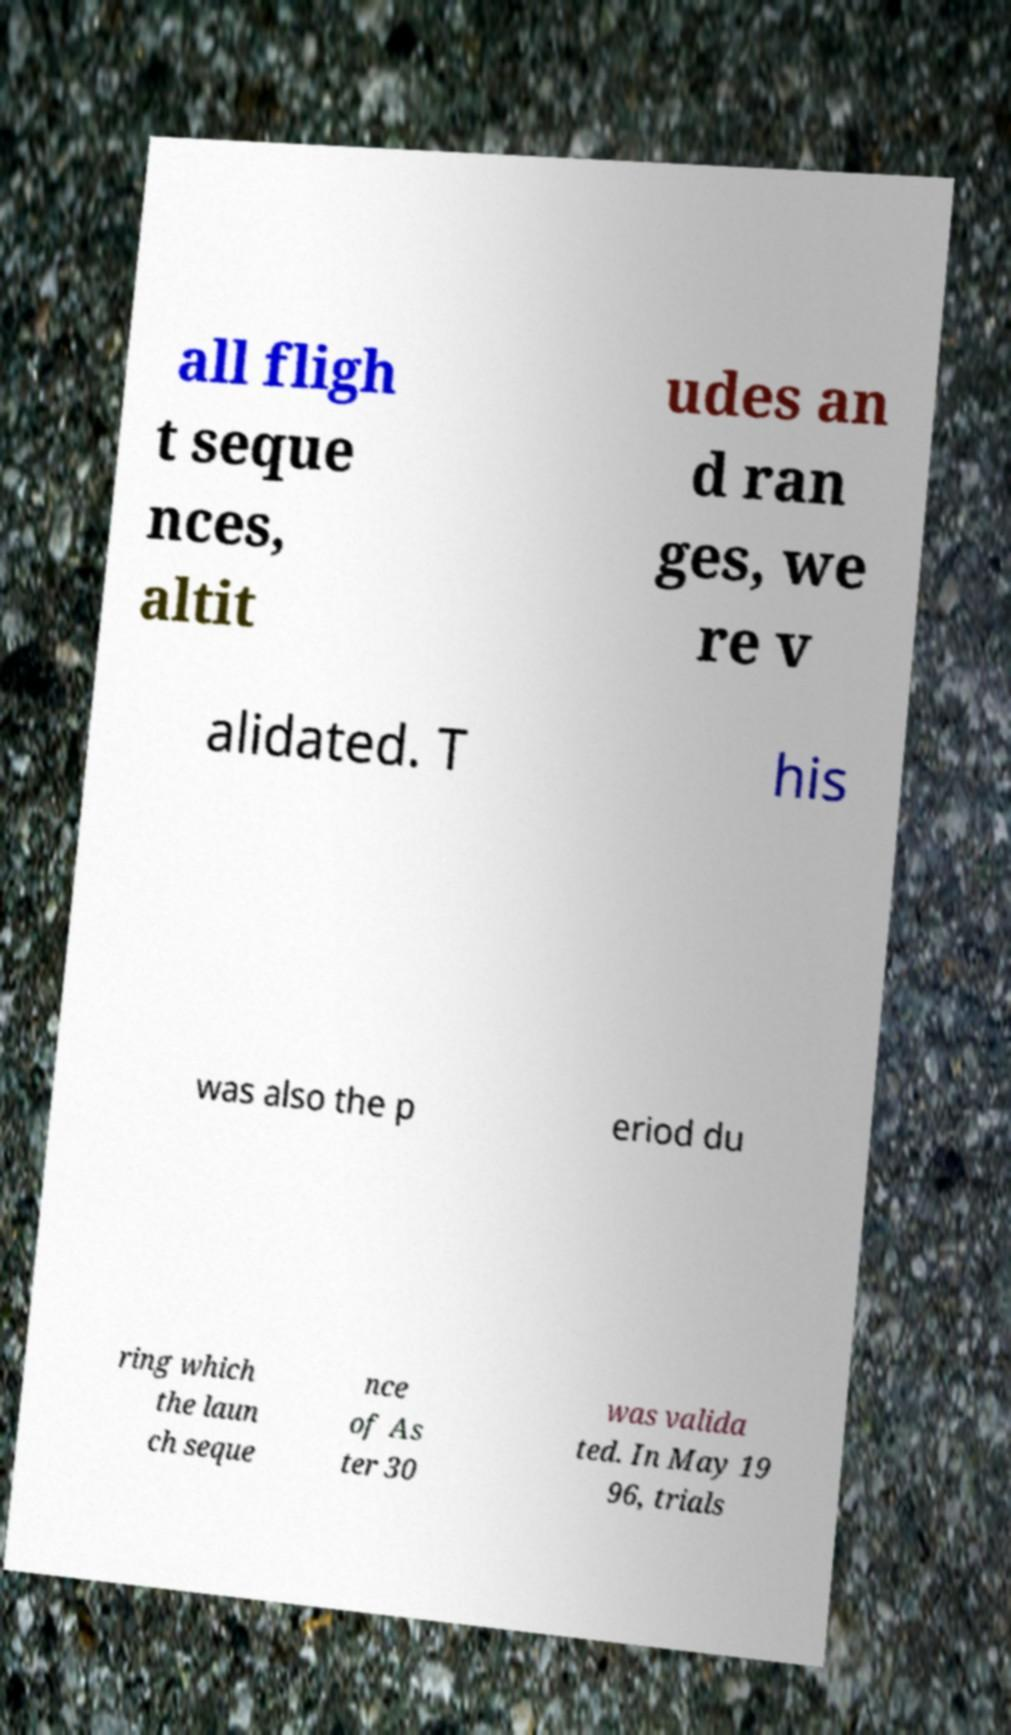I need the written content from this picture converted into text. Can you do that? all fligh t seque nces, altit udes an d ran ges, we re v alidated. T his was also the p eriod du ring which the laun ch seque nce of As ter 30 was valida ted. In May 19 96, trials 